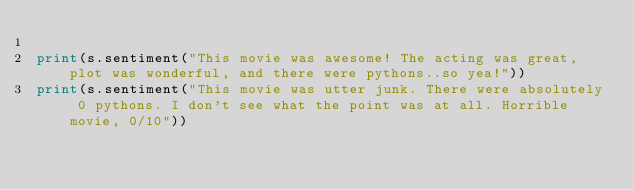Convert code to text. <code><loc_0><loc_0><loc_500><loc_500><_Python_>
print(s.sentiment("This movie was awesome! The acting was great, plot was wonderful, and there were pythons..so yea!"))
print(s.sentiment("This movie was utter junk. There were absolutely 0 pythons. I don't see what the point was at all. Horrible movie, 0/10"))
</code> 